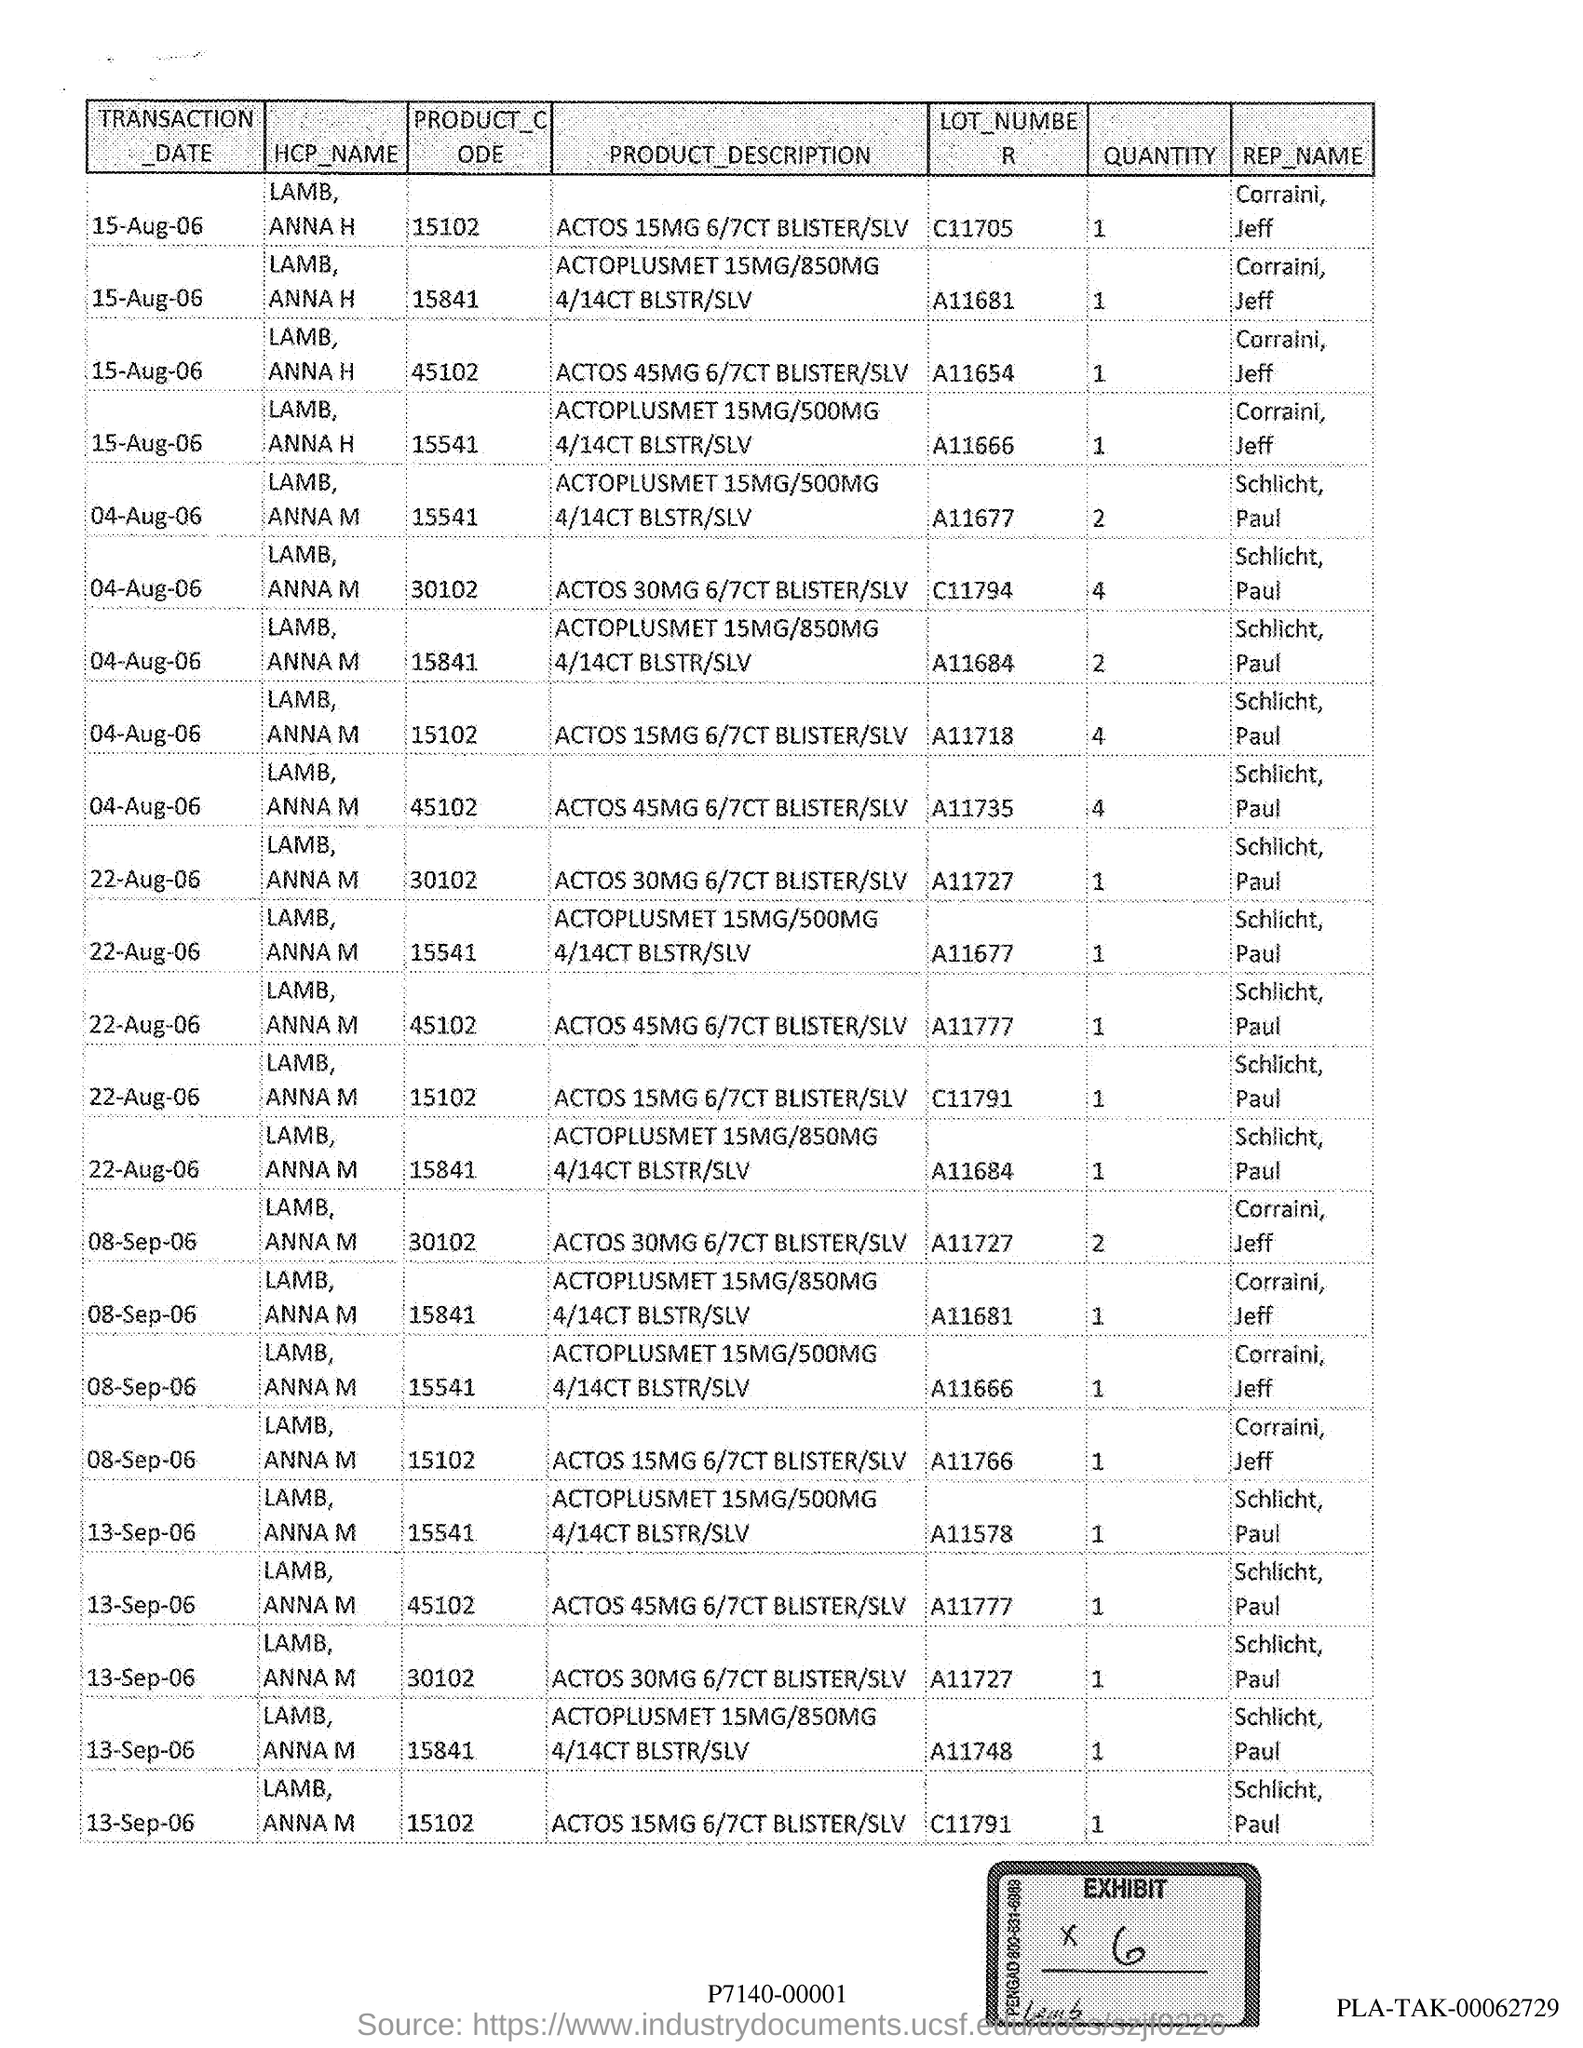Highlight a few significant elements in this photo. I'm sorry, I'm not sure what you are asking for. Could you please provide more context or clarify your question? 